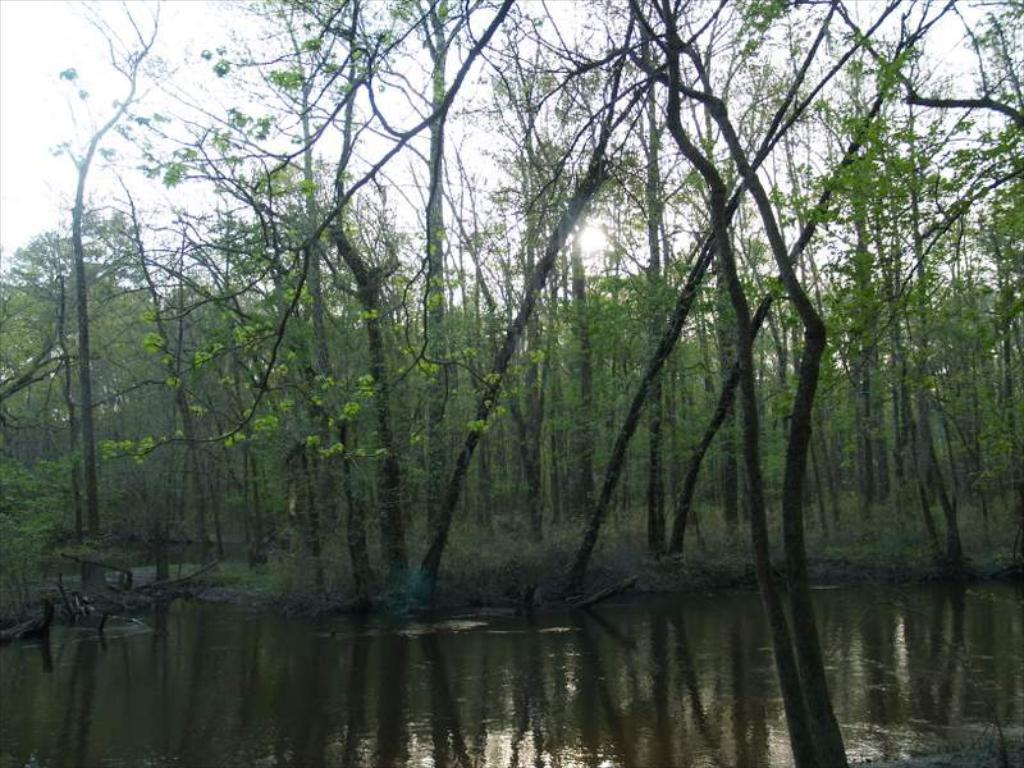What is the primary element visible in the picture? There is water in the picture. What type of vegetation can be seen around the water? There are many trees around the water. How many women are present in the image? There is no information about women in the image, as it only features water and trees. 